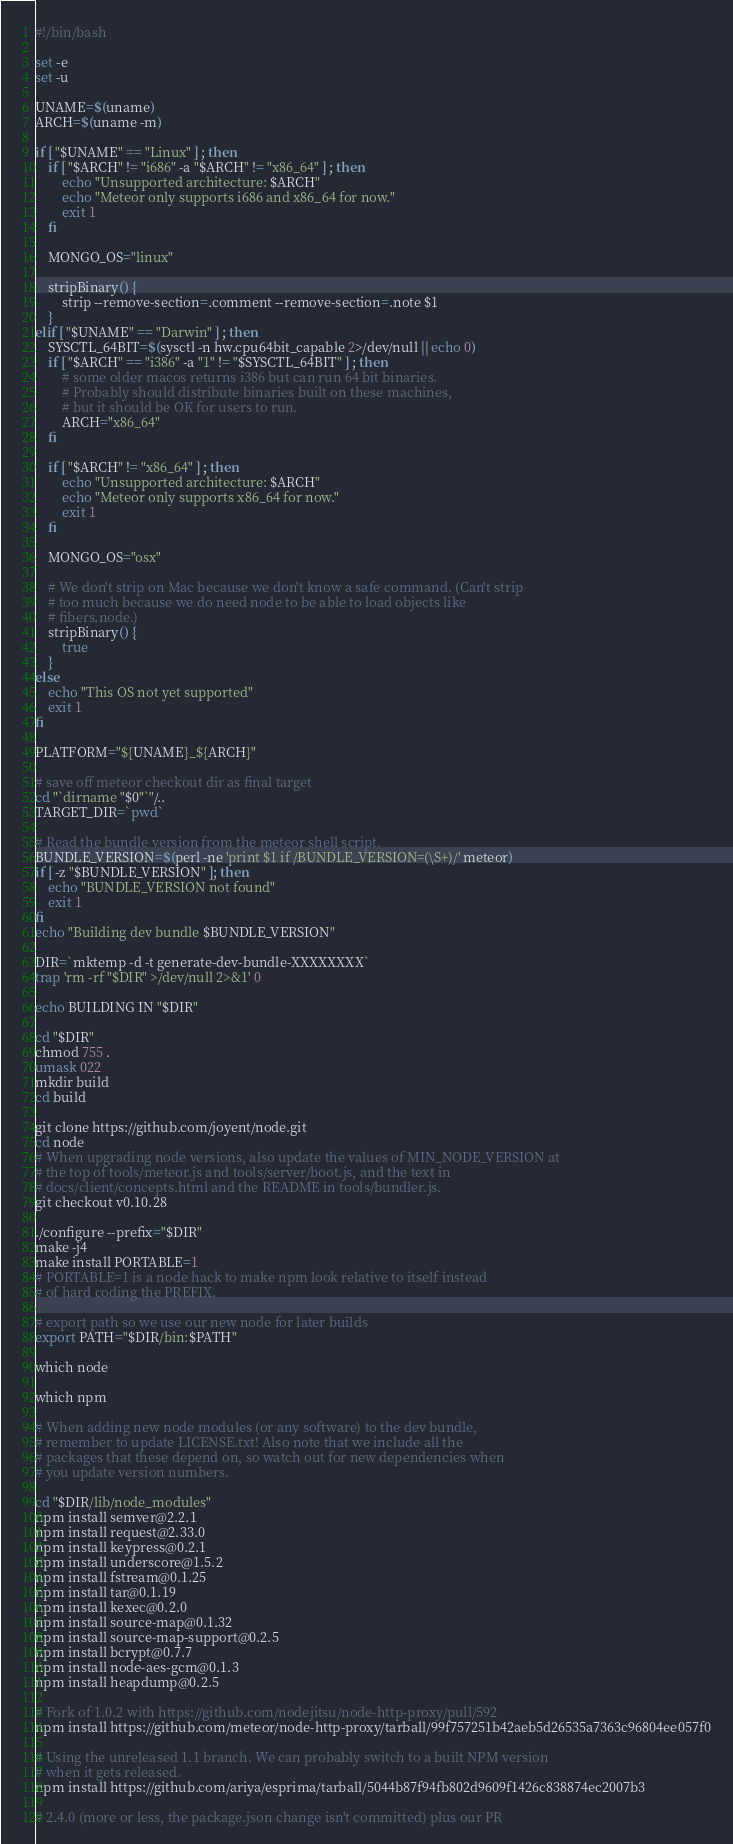Convert code to text. <code><loc_0><loc_0><loc_500><loc_500><_Bash_>#!/bin/bash

set -e
set -u

UNAME=$(uname)
ARCH=$(uname -m)

if [ "$UNAME" == "Linux" ] ; then
    if [ "$ARCH" != "i686" -a "$ARCH" != "x86_64" ] ; then
        echo "Unsupported architecture: $ARCH"
        echo "Meteor only supports i686 and x86_64 for now."
        exit 1
    fi

    MONGO_OS="linux"

    stripBinary() {
        strip --remove-section=.comment --remove-section=.note $1
    }
elif [ "$UNAME" == "Darwin" ] ; then
    SYSCTL_64BIT=$(sysctl -n hw.cpu64bit_capable 2>/dev/null || echo 0)
    if [ "$ARCH" == "i386" -a "1" != "$SYSCTL_64BIT" ] ; then
        # some older macos returns i386 but can run 64 bit binaries.
        # Probably should distribute binaries built on these machines,
        # but it should be OK for users to run.
        ARCH="x86_64"
    fi

    if [ "$ARCH" != "x86_64" ] ; then
        echo "Unsupported architecture: $ARCH"
        echo "Meteor only supports x86_64 for now."
        exit 1
    fi

    MONGO_OS="osx"

    # We don't strip on Mac because we don't know a safe command. (Can't strip
    # too much because we do need node to be able to load objects like
    # fibers.node.)
    stripBinary() {
        true
    }
else
    echo "This OS not yet supported"
    exit 1
fi

PLATFORM="${UNAME}_${ARCH}"

# save off meteor checkout dir as final target
cd "`dirname "$0"`"/..
TARGET_DIR=`pwd`

# Read the bundle version from the meteor shell script.
BUNDLE_VERSION=$(perl -ne 'print $1 if /BUNDLE_VERSION=(\S+)/' meteor)
if [ -z "$BUNDLE_VERSION" ]; then
    echo "BUNDLE_VERSION not found"
    exit 1
fi
echo "Building dev bundle $BUNDLE_VERSION"

DIR=`mktemp -d -t generate-dev-bundle-XXXXXXXX`
trap 'rm -rf "$DIR" >/dev/null 2>&1' 0

echo BUILDING IN "$DIR"

cd "$DIR"
chmod 755 .
umask 022
mkdir build
cd build

git clone https://github.com/joyent/node.git
cd node
# When upgrading node versions, also update the values of MIN_NODE_VERSION at
# the top of tools/meteor.js and tools/server/boot.js, and the text in
# docs/client/concepts.html and the README in tools/bundler.js.
git checkout v0.10.28

./configure --prefix="$DIR"
make -j4
make install PORTABLE=1
# PORTABLE=1 is a node hack to make npm look relative to itself instead
# of hard coding the PREFIX.

# export path so we use our new node for later builds
export PATH="$DIR/bin:$PATH"

which node

which npm

# When adding new node modules (or any software) to the dev bundle,
# remember to update LICENSE.txt! Also note that we include all the
# packages that these depend on, so watch out for new dependencies when
# you update version numbers.

cd "$DIR/lib/node_modules"
npm install semver@2.2.1
npm install request@2.33.0
npm install keypress@0.2.1
npm install underscore@1.5.2
npm install fstream@0.1.25
npm install tar@0.1.19
npm install kexec@0.2.0
npm install source-map@0.1.32
npm install source-map-support@0.2.5
npm install bcrypt@0.7.7
npm install node-aes-gcm@0.1.3
npm install heapdump@0.2.5

# Fork of 1.0.2 with https://github.com/nodejitsu/node-http-proxy/pull/592
npm install https://github.com/meteor/node-http-proxy/tarball/99f757251b42aeb5d26535a7363c96804ee057f0

# Using the unreleased 1.1 branch. We can probably switch to a built NPM version
# when it gets released.
npm install https://github.com/ariya/esprima/tarball/5044b87f94fb802d9609f1426c838874ec2007b3

# 2.4.0 (more or less, the package.json change isn't committed) plus our PR</code> 